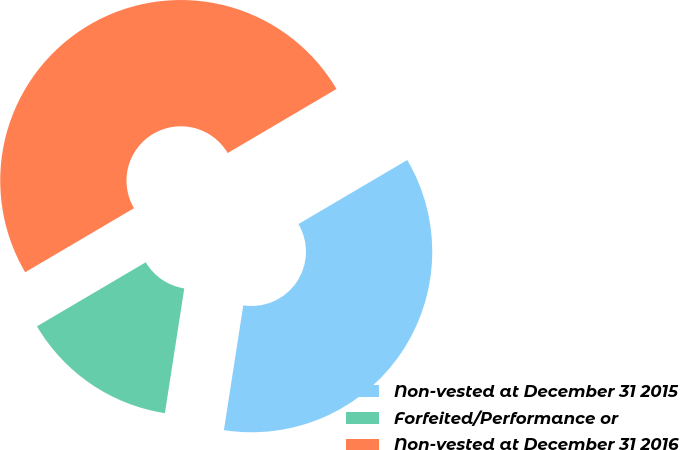Convert chart to OTSL. <chart><loc_0><loc_0><loc_500><loc_500><pie_chart><fcel>Non-vested at December 31 2015<fcel>Forfeited/Performance or<fcel>Non-vested at December 31 2016<nl><fcel>35.92%<fcel>14.08%<fcel>50.0%<nl></chart> 